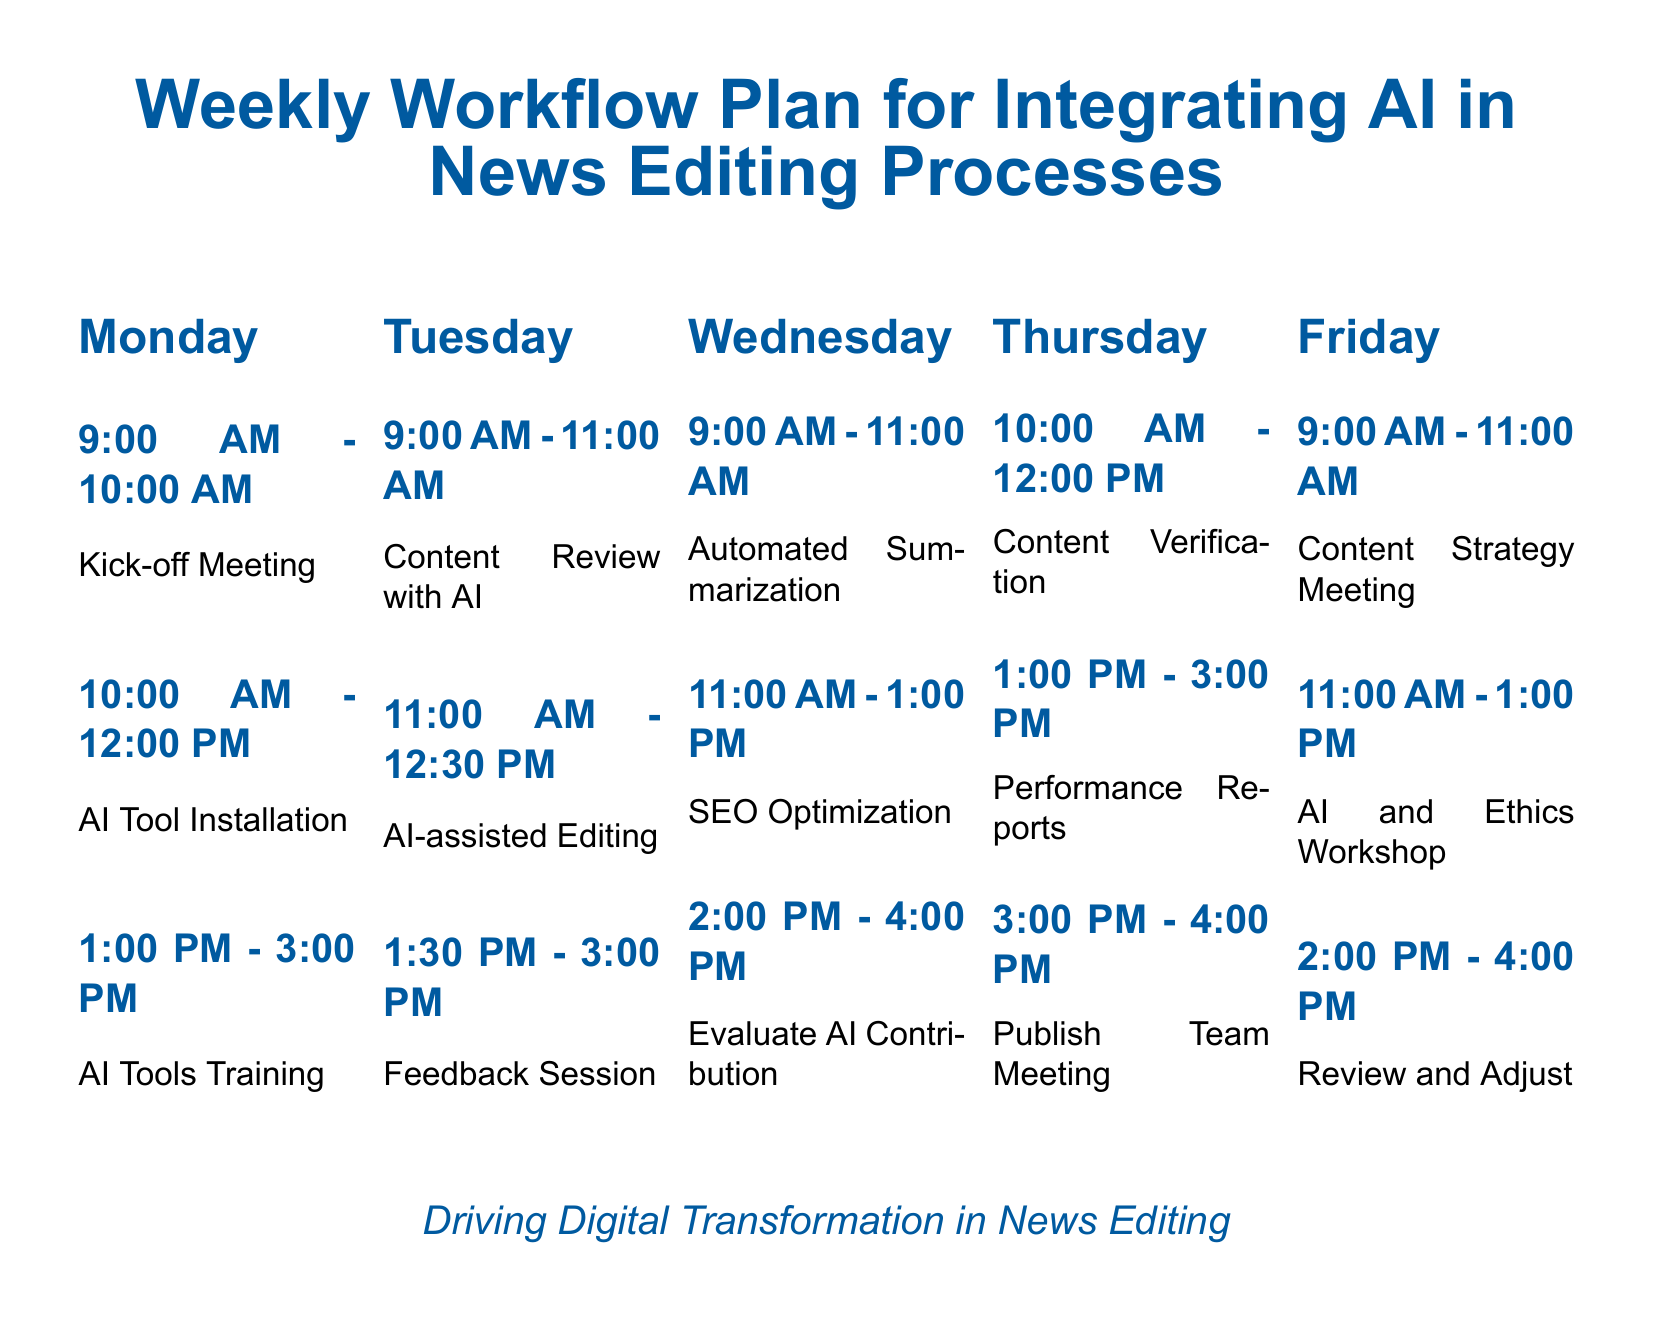What is the meeting time on Monday? The meeting time on Monday is specified as 9:00 AM - 10:00 AM for the Kick-off Meeting.
Answer: 9:00 AM - 10:00 AM How long is the AI Tools Training session on Monday? The AI Tools Training session on Monday lasts from 1:00 PM to 3:00 PM, which is 2 hours.
Answer: 2 hours What activity takes place first on Wednesday? The first activity on Wednesday is Automated Summarization, starting at 9:00 AM.
Answer: Automated Summarization What is the focus of the workshop on Friday? The focus of the workshop on Friday is on AI and ethics, as mentioned in the schedule.
Answer: AI and Ethics Workshop Which day has a Feedback Session scheduled? The Feedback Session is scheduled on Tuesday from 1:30 PM to 3:00 PM.
Answer: Tuesday How many hours are allocated for content review with AI on Tuesday? The content review with AI on Tuesday is allocated 2 hours, from 9:00 AM to 11:00 AM.
Answer: 2 hours What happens after the Performance Reports on Thursday? After the Performance Reports on Thursday, the Publish Team Meeting takes place.
Answer: Publish Team Meeting Which day's activities primarily involve AI tools? Activities primarily involving AI tools are scheduled on Tuesday and Wednesday.
Answer: Tuesday and Wednesday 